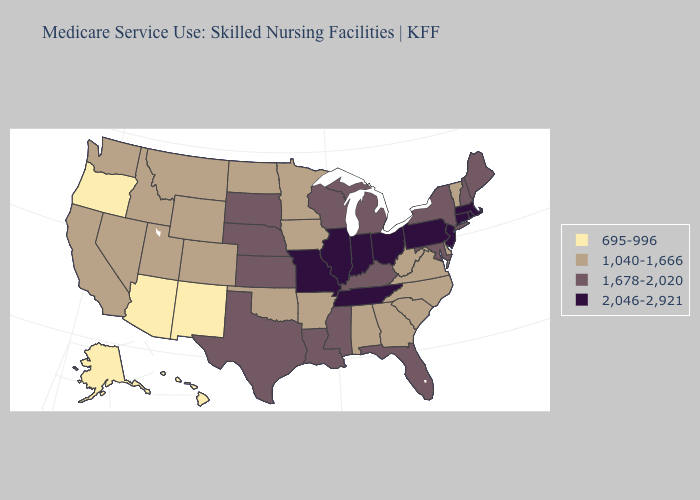Does New Mexico have the lowest value in the USA?
Short answer required. Yes. Among the states that border Texas , does Louisiana have the highest value?
Keep it brief. Yes. Name the states that have a value in the range 2,046-2,921?
Short answer required. Connecticut, Illinois, Indiana, Massachusetts, Missouri, New Jersey, Ohio, Pennsylvania, Rhode Island, Tennessee. Name the states that have a value in the range 1,678-2,020?
Quick response, please. Florida, Kansas, Kentucky, Louisiana, Maine, Maryland, Michigan, Mississippi, Nebraska, New Hampshire, New York, South Dakota, Texas, Wisconsin. Does the map have missing data?
Concise answer only. No. What is the lowest value in the South?
Write a very short answer. 1,040-1,666. Name the states that have a value in the range 695-996?
Keep it brief. Alaska, Arizona, Hawaii, New Mexico, Oregon. Does Hawaii have the same value as New Mexico?
Answer briefly. Yes. Name the states that have a value in the range 1,678-2,020?
Quick response, please. Florida, Kansas, Kentucky, Louisiana, Maine, Maryland, Michigan, Mississippi, Nebraska, New Hampshire, New York, South Dakota, Texas, Wisconsin. What is the lowest value in the USA?
Short answer required. 695-996. What is the lowest value in the West?
Keep it brief. 695-996. Which states hav the highest value in the MidWest?
Short answer required. Illinois, Indiana, Missouri, Ohio. What is the value of North Dakota?
Be succinct. 1,040-1,666. Name the states that have a value in the range 1,678-2,020?
Be succinct. Florida, Kansas, Kentucky, Louisiana, Maine, Maryland, Michigan, Mississippi, Nebraska, New Hampshire, New York, South Dakota, Texas, Wisconsin. What is the value of New Mexico?
Short answer required. 695-996. 